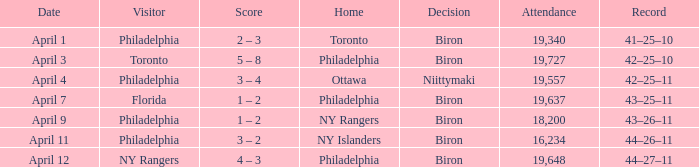What was the flyers' record when the visitors were florida? 43–25–11. 